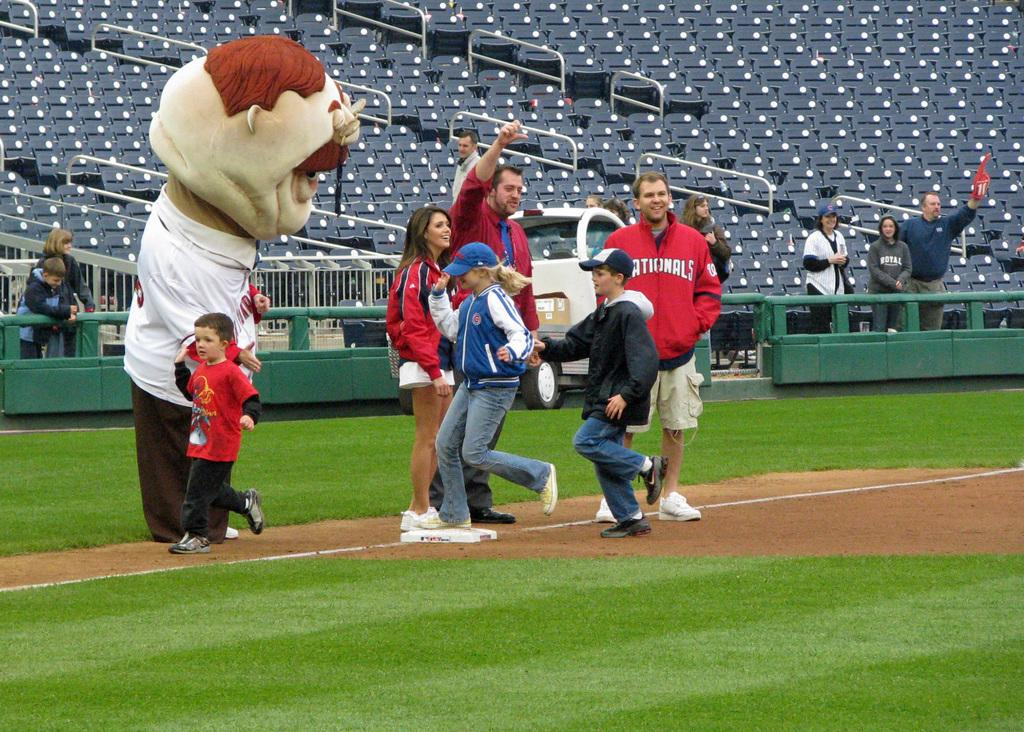<image>
Offer a succinct explanation of the picture presented. A group of people, a mascot and a man wearing a Cardinals jacket. 